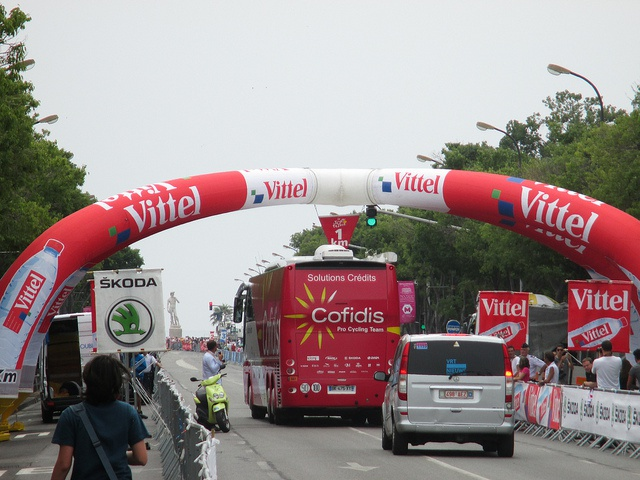Describe the objects in this image and their specific colors. I can see bus in lightgray, brown, maroon, and black tones, car in lightgray, black, darkgray, and gray tones, people in lightgray, black, maroon, gray, and blue tones, truck in lightgray, black, darkgray, and gray tones, and motorcycle in lightgray, black, gray, olive, and darkgray tones in this image. 